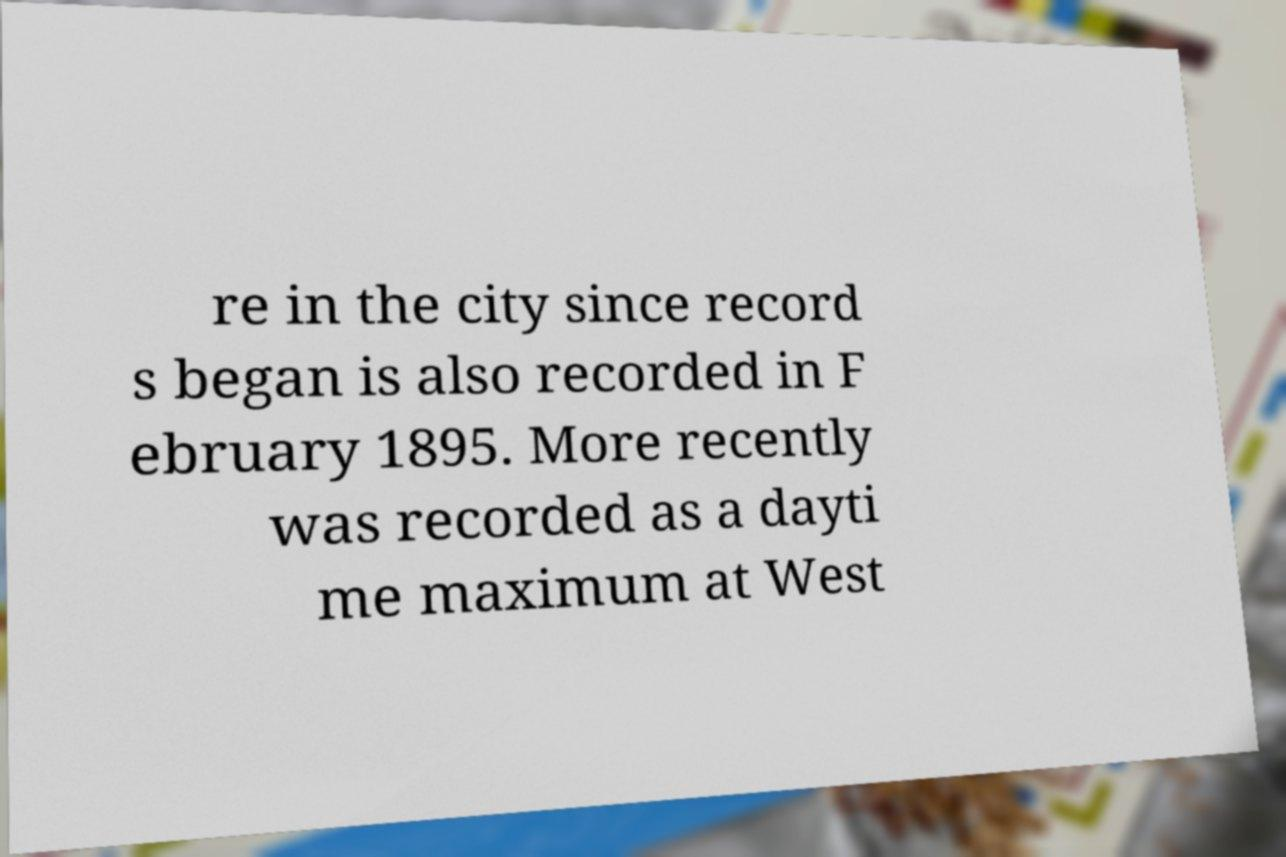Could you extract and type out the text from this image? re in the city since record s began is also recorded in F ebruary 1895. More recently was recorded as a dayti me maximum at West 